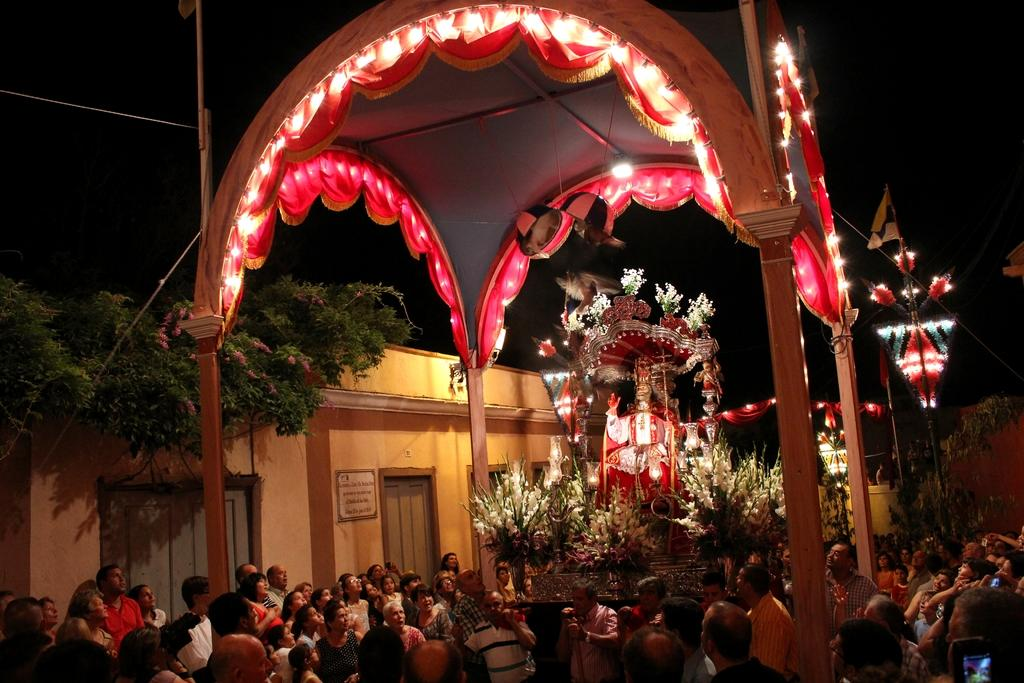What type of structure can be seen in the image? There is an arch in the image. What is located near the arch? There is a statue in the image. What decorative elements are present in the image? There are flowers and lights in the image. What type of vegetation is present in the image? There are plants in the image. Are there any people in the image? Yes, there are people standing in the image. What are the people doing or looking at? The people are looking towards the statue. What type of hat is the statue wearing in the image? The statue in the image is not wearing a hat; it is a statue and does not have clothing or accessories. Are there any socks visible on the plants in the image? There are no socks present in the image; it features an arch, a statue, flowers, lights, plants, and people. 